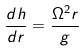Convert formula to latex. <formula><loc_0><loc_0><loc_500><loc_500>\frac { d h } { d r } = \frac { \Omega ^ { 2 } r } { g }</formula> 